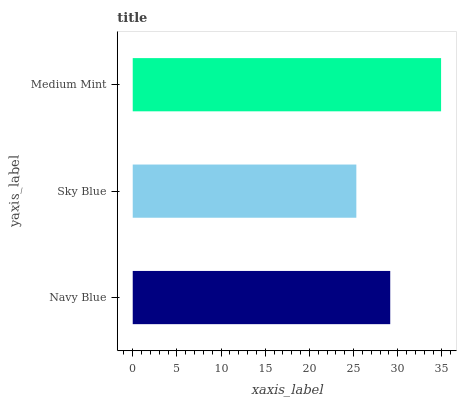Is Sky Blue the minimum?
Answer yes or no. Yes. Is Medium Mint the maximum?
Answer yes or no. Yes. Is Medium Mint the minimum?
Answer yes or no. No. Is Sky Blue the maximum?
Answer yes or no. No. Is Medium Mint greater than Sky Blue?
Answer yes or no. Yes. Is Sky Blue less than Medium Mint?
Answer yes or no. Yes. Is Sky Blue greater than Medium Mint?
Answer yes or no. No. Is Medium Mint less than Sky Blue?
Answer yes or no. No. Is Navy Blue the high median?
Answer yes or no. Yes. Is Navy Blue the low median?
Answer yes or no. Yes. Is Medium Mint the high median?
Answer yes or no. No. Is Sky Blue the low median?
Answer yes or no. No. 